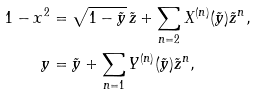<formula> <loc_0><loc_0><loc_500><loc_500>1 - x ^ { 2 } & = \sqrt { 1 - \tilde { y } } \, \tilde { z } + \sum _ { n = 2 } X ^ { ( n ) } ( \tilde { y } ) \tilde { z } ^ { n } , \\ y & = \tilde { y } + \sum _ { n = 1 } Y ^ { ( n ) } ( \tilde { y } ) \tilde { z } ^ { n } ,</formula> 